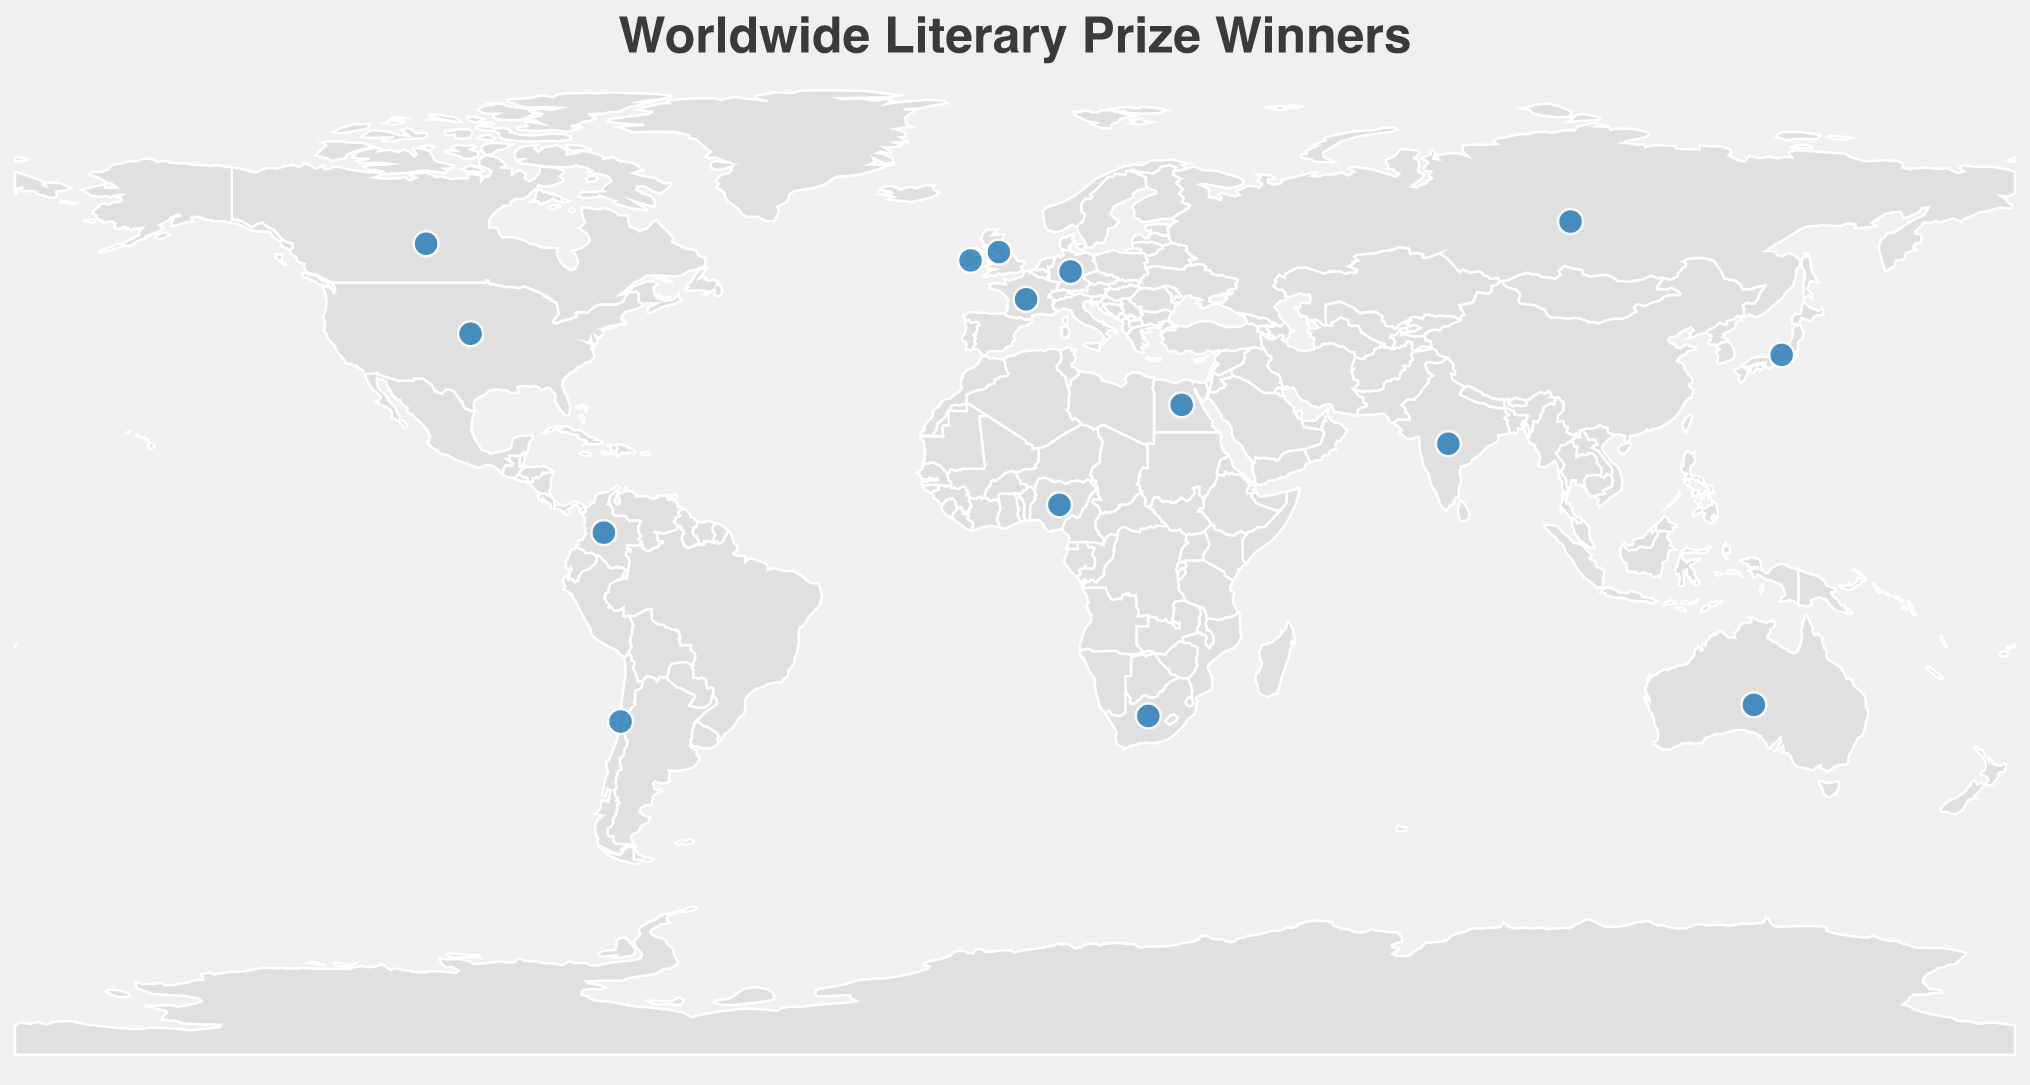What's the title of the plot? The title of the plot is usually at the top center of the figure. In this case, it is written in a larger font size and indicates what the plot is about. The title here reads "Worldwide Literary Prize Winners".
Answer: Worldwide Literary Prize Winners How many authors from Africa are shown on the plot? By examining the locations marked with circles on the map of Africa, we can see that there are two entries: one for Nigeria and one for South Africa. This means there are two African authors shown in the plot.
Answer: 2 Which country has the earliest literary prize winner in the dataset? To determine the earliest prize winner, observe the "Year" field in the tooltips of all the data points. The earliest year shown on the figure is 1919 for Marcel Proust from France.
Answer: France What's the average year of the prize winners from the Northern Hemisphere? First, identify and list the years of the winners from countries in the Northern Hemisphere (United Kingdom - 2017, Colombia - 1982, United States - 2014, Nigeria - 2007, France - 1919, Japan - 1987, Canada - 1985, Russia - 2001, India - 2006, Germany - 2009, Ireland - 2011, Egypt - 2002). Then, sum these years and divide by the number of winners. 
The total sum is (2017 + 1982 + 2014 + 2007 + 1919 + 1987 + 1985 + 2001 + 2006 + 2009 + 2011 + 2002) = 23840. There are 12 winners, so the average year is 23840 / 12 ≈ 1987.
Answer: ~1987 Are there more prize winners from Europe or Asia? Count the number of prize winners from countries in Europe (United Kingdom, France, Germany, Russia, Ireland) and Asia (Japan, India). Europe has 5 winners and Asia has 2. Therefore, Europe has more prize winners.
Answer: Europe Which literary prize is most frequently awarded to authors in the figure? By examining the tooltips for all data points, count the frequency of each prize mentioned. Each prize appears exactly once, so none is more frequent than the others.
Answer: None is more frequent Which two countries have prize winners closest in year to one another? To find the pair, compare the years of prize winners and calculate the differences:
- 2017 (UK) and 2014 (US) have a difference of 3 years.
- Other pairs have larger differences: e.g., 2014 (US) and 2011 (Ireland) have a difference of 3 years, which is similar.
Thus, 2017 (UK) and 2014 (US) and 2014 (US) and 2011 (Ireland) are pairs with the smallest difference of 3 years.
Answer: UK-US and US-Ireland Which region shows a literary prize winner named after a local literary figure? Look for prize names that specify regional figures. The Akutagawa Prize in Japan is named after the Japanese writer Akutagawa Ryūnosuke, and the Naguib Mahfouz Medal for Literature in Egypt is named after the Egyptian writer Naguib Mahfouz.
Answer: Japan and Egypt In which regions do the prize winners' countries primarily cluster, considering all continents? The visual distribution shows clusters in Europe, North America, and Africa with scattered points in South America, Asia, and Oceania. By examining the spread of data points, the clustering is most prominent in Europe and North America.
Answer: Europe and North America 